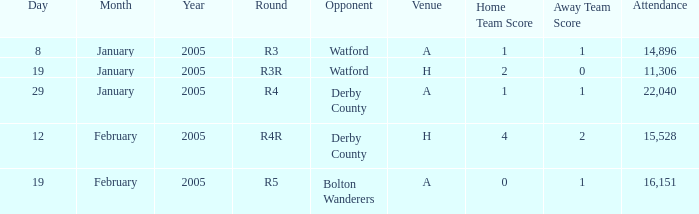What is the round of the game at venue H and opponent of Derby County? R4R. 